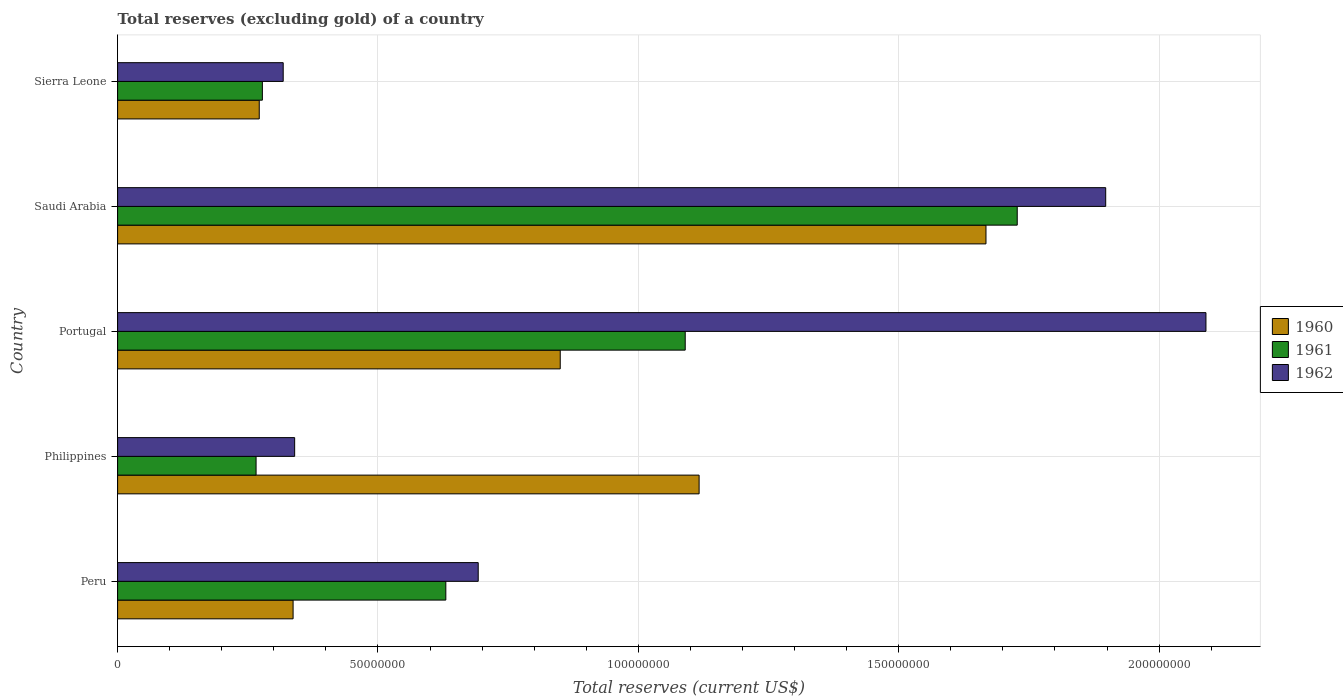How many groups of bars are there?
Your answer should be compact. 5. Are the number of bars on each tick of the Y-axis equal?
Offer a terse response. Yes. How many bars are there on the 3rd tick from the top?
Give a very brief answer. 3. In how many cases, is the number of bars for a given country not equal to the number of legend labels?
Provide a short and direct response. 0. What is the total reserves (excluding gold) in 1962 in Saudi Arabia?
Provide a succinct answer. 1.90e+08. Across all countries, what is the maximum total reserves (excluding gold) in 1960?
Your answer should be very brief. 1.67e+08. Across all countries, what is the minimum total reserves (excluding gold) in 1960?
Provide a succinct answer. 2.72e+07. In which country was the total reserves (excluding gold) in 1961 maximum?
Your response must be concise. Saudi Arabia. In which country was the total reserves (excluding gold) in 1962 minimum?
Keep it short and to the point. Sierra Leone. What is the total total reserves (excluding gold) in 1960 in the graph?
Make the answer very short. 4.24e+08. What is the difference between the total reserves (excluding gold) in 1960 in Saudi Arabia and that in Sierra Leone?
Offer a terse response. 1.40e+08. What is the difference between the total reserves (excluding gold) in 1960 in Peru and the total reserves (excluding gold) in 1961 in Portugal?
Ensure brevity in your answer.  -7.53e+07. What is the average total reserves (excluding gold) in 1961 per country?
Offer a terse response. 7.98e+07. What is the difference between the total reserves (excluding gold) in 1960 and total reserves (excluding gold) in 1962 in Sierra Leone?
Offer a very short reply. -4.60e+06. What is the ratio of the total reserves (excluding gold) in 1962 in Philippines to that in Portugal?
Give a very brief answer. 0.16. Is the difference between the total reserves (excluding gold) in 1960 in Peru and Sierra Leone greater than the difference between the total reserves (excluding gold) in 1962 in Peru and Sierra Leone?
Provide a succinct answer. No. What is the difference between the highest and the second highest total reserves (excluding gold) in 1962?
Your answer should be compact. 1.92e+07. What is the difference between the highest and the lowest total reserves (excluding gold) in 1960?
Offer a terse response. 1.40e+08. In how many countries, is the total reserves (excluding gold) in 1961 greater than the average total reserves (excluding gold) in 1961 taken over all countries?
Provide a short and direct response. 2. Is the sum of the total reserves (excluding gold) in 1961 in Peru and Portugal greater than the maximum total reserves (excluding gold) in 1962 across all countries?
Provide a succinct answer. No. What does the 3rd bar from the top in Portugal represents?
Ensure brevity in your answer.  1960. How many bars are there?
Provide a succinct answer. 15. What is the difference between two consecutive major ticks on the X-axis?
Offer a very short reply. 5.00e+07. Where does the legend appear in the graph?
Give a very brief answer. Center right. How many legend labels are there?
Your answer should be very brief. 3. What is the title of the graph?
Your answer should be very brief. Total reserves (excluding gold) of a country. Does "1983" appear as one of the legend labels in the graph?
Provide a short and direct response. No. What is the label or title of the X-axis?
Provide a short and direct response. Total reserves (current US$). What is the Total reserves (current US$) of 1960 in Peru?
Your answer should be compact. 3.37e+07. What is the Total reserves (current US$) of 1961 in Peru?
Give a very brief answer. 6.30e+07. What is the Total reserves (current US$) in 1962 in Peru?
Ensure brevity in your answer.  6.92e+07. What is the Total reserves (current US$) in 1960 in Philippines?
Ensure brevity in your answer.  1.12e+08. What is the Total reserves (current US$) in 1961 in Philippines?
Offer a very short reply. 2.66e+07. What is the Total reserves (current US$) of 1962 in Philippines?
Your response must be concise. 3.40e+07. What is the Total reserves (current US$) in 1960 in Portugal?
Offer a terse response. 8.50e+07. What is the Total reserves (current US$) in 1961 in Portugal?
Your answer should be very brief. 1.09e+08. What is the Total reserves (current US$) in 1962 in Portugal?
Your answer should be very brief. 2.09e+08. What is the Total reserves (current US$) of 1960 in Saudi Arabia?
Your answer should be very brief. 1.67e+08. What is the Total reserves (current US$) of 1961 in Saudi Arabia?
Give a very brief answer. 1.73e+08. What is the Total reserves (current US$) of 1962 in Saudi Arabia?
Offer a terse response. 1.90e+08. What is the Total reserves (current US$) of 1960 in Sierra Leone?
Make the answer very short. 2.72e+07. What is the Total reserves (current US$) of 1961 in Sierra Leone?
Make the answer very short. 2.78e+07. What is the Total reserves (current US$) in 1962 in Sierra Leone?
Offer a terse response. 3.18e+07. Across all countries, what is the maximum Total reserves (current US$) of 1960?
Give a very brief answer. 1.67e+08. Across all countries, what is the maximum Total reserves (current US$) of 1961?
Provide a succinct answer. 1.73e+08. Across all countries, what is the maximum Total reserves (current US$) in 1962?
Your response must be concise. 2.09e+08. Across all countries, what is the minimum Total reserves (current US$) in 1960?
Offer a terse response. 2.72e+07. Across all countries, what is the minimum Total reserves (current US$) of 1961?
Give a very brief answer. 2.66e+07. Across all countries, what is the minimum Total reserves (current US$) in 1962?
Offer a very short reply. 3.18e+07. What is the total Total reserves (current US$) in 1960 in the graph?
Keep it short and to the point. 4.24e+08. What is the total Total reserves (current US$) of 1961 in the graph?
Offer a terse response. 3.99e+08. What is the total Total reserves (current US$) in 1962 in the graph?
Give a very brief answer. 5.34e+08. What is the difference between the Total reserves (current US$) of 1960 in Peru and that in Philippines?
Keep it short and to the point. -7.80e+07. What is the difference between the Total reserves (current US$) of 1961 in Peru and that in Philippines?
Your response must be concise. 3.64e+07. What is the difference between the Total reserves (current US$) in 1962 in Peru and that in Philippines?
Offer a terse response. 3.52e+07. What is the difference between the Total reserves (current US$) in 1960 in Peru and that in Portugal?
Your answer should be very brief. -5.13e+07. What is the difference between the Total reserves (current US$) in 1961 in Peru and that in Portugal?
Offer a terse response. -4.60e+07. What is the difference between the Total reserves (current US$) in 1962 in Peru and that in Portugal?
Keep it short and to the point. -1.40e+08. What is the difference between the Total reserves (current US$) of 1960 in Peru and that in Saudi Arabia?
Offer a terse response. -1.33e+08. What is the difference between the Total reserves (current US$) in 1961 in Peru and that in Saudi Arabia?
Your answer should be compact. -1.10e+08. What is the difference between the Total reserves (current US$) in 1962 in Peru and that in Saudi Arabia?
Offer a terse response. -1.20e+08. What is the difference between the Total reserves (current US$) in 1960 in Peru and that in Sierra Leone?
Offer a terse response. 6.50e+06. What is the difference between the Total reserves (current US$) in 1961 in Peru and that in Sierra Leone?
Your answer should be compact. 3.52e+07. What is the difference between the Total reserves (current US$) in 1962 in Peru and that in Sierra Leone?
Provide a short and direct response. 3.74e+07. What is the difference between the Total reserves (current US$) in 1960 in Philippines and that in Portugal?
Offer a very short reply. 2.67e+07. What is the difference between the Total reserves (current US$) of 1961 in Philippines and that in Portugal?
Make the answer very short. -8.24e+07. What is the difference between the Total reserves (current US$) of 1962 in Philippines and that in Portugal?
Your answer should be compact. -1.75e+08. What is the difference between the Total reserves (current US$) of 1960 in Philippines and that in Saudi Arabia?
Make the answer very short. -5.51e+07. What is the difference between the Total reserves (current US$) in 1961 in Philippines and that in Saudi Arabia?
Provide a succinct answer. -1.46e+08. What is the difference between the Total reserves (current US$) in 1962 in Philippines and that in Saudi Arabia?
Your response must be concise. -1.56e+08. What is the difference between the Total reserves (current US$) of 1960 in Philippines and that in Sierra Leone?
Your answer should be compact. 8.45e+07. What is the difference between the Total reserves (current US$) in 1961 in Philippines and that in Sierra Leone?
Your response must be concise. -1.21e+06. What is the difference between the Total reserves (current US$) in 1962 in Philippines and that in Sierra Leone?
Provide a succinct answer. 2.20e+06. What is the difference between the Total reserves (current US$) in 1960 in Portugal and that in Saudi Arabia?
Provide a succinct answer. -8.18e+07. What is the difference between the Total reserves (current US$) of 1961 in Portugal and that in Saudi Arabia?
Provide a short and direct response. -6.38e+07. What is the difference between the Total reserves (current US$) of 1962 in Portugal and that in Saudi Arabia?
Give a very brief answer. 1.92e+07. What is the difference between the Total reserves (current US$) of 1960 in Portugal and that in Sierra Leone?
Provide a succinct answer. 5.78e+07. What is the difference between the Total reserves (current US$) of 1961 in Portugal and that in Sierra Leone?
Make the answer very short. 8.12e+07. What is the difference between the Total reserves (current US$) of 1962 in Portugal and that in Sierra Leone?
Your answer should be very brief. 1.77e+08. What is the difference between the Total reserves (current US$) of 1960 in Saudi Arabia and that in Sierra Leone?
Provide a succinct answer. 1.40e+08. What is the difference between the Total reserves (current US$) of 1961 in Saudi Arabia and that in Sierra Leone?
Provide a short and direct response. 1.45e+08. What is the difference between the Total reserves (current US$) of 1962 in Saudi Arabia and that in Sierra Leone?
Your answer should be very brief. 1.58e+08. What is the difference between the Total reserves (current US$) in 1960 in Peru and the Total reserves (current US$) in 1961 in Philippines?
Your response must be concise. 7.11e+06. What is the difference between the Total reserves (current US$) of 1960 in Peru and the Total reserves (current US$) of 1962 in Philippines?
Provide a succinct answer. -3.00e+05. What is the difference between the Total reserves (current US$) in 1961 in Peru and the Total reserves (current US$) in 1962 in Philippines?
Give a very brief answer. 2.90e+07. What is the difference between the Total reserves (current US$) in 1960 in Peru and the Total reserves (current US$) in 1961 in Portugal?
Offer a very short reply. -7.53e+07. What is the difference between the Total reserves (current US$) in 1960 in Peru and the Total reserves (current US$) in 1962 in Portugal?
Make the answer very short. -1.75e+08. What is the difference between the Total reserves (current US$) of 1961 in Peru and the Total reserves (current US$) of 1962 in Portugal?
Your response must be concise. -1.46e+08. What is the difference between the Total reserves (current US$) in 1960 in Peru and the Total reserves (current US$) in 1961 in Saudi Arabia?
Offer a terse response. -1.39e+08. What is the difference between the Total reserves (current US$) in 1960 in Peru and the Total reserves (current US$) in 1962 in Saudi Arabia?
Give a very brief answer. -1.56e+08. What is the difference between the Total reserves (current US$) in 1961 in Peru and the Total reserves (current US$) in 1962 in Saudi Arabia?
Provide a short and direct response. -1.27e+08. What is the difference between the Total reserves (current US$) of 1960 in Peru and the Total reserves (current US$) of 1961 in Sierra Leone?
Your answer should be compact. 5.90e+06. What is the difference between the Total reserves (current US$) of 1960 in Peru and the Total reserves (current US$) of 1962 in Sierra Leone?
Make the answer very short. 1.90e+06. What is the difference between the Total reserves (current US$) in 1961 in Peru and the Total reserves (current US$) in 1962 in Sierra Leone?
Your answer should be compact. 3.12e+07. What is the difference between the Total reserves (current US$) of 1960 in Philippines and the Total reserves (current US$) of 1961 in Portugal?
Offer a terse response. 2.67e+06. What is the difference between the Total reserves (current US$) of 1960 in Philippines and the Total reserves (current US$) of 1962 in Portugal?
Keep it short and to the point. -9.73e+07. What is the difference between the Total reserves (current US$) in 1961 in Philippines and the Total reserves (current US$) in 1962 in Portugal?
Make the answer very short. -1.82e+08. What is the difference between the Total reserves (current US$) in 1960 in Philippines and the Total reserves (current US$) in 1961 in Saudi Arabia?
Provide a short and direct response. -6.11e+07. What is the difference between the Total reserves (current US$) in 1960 in Philippines and the Total reserves (current US$) in 1962 in Saudi Arabia?
Provide a succinct answer. -7.81e+07. What is the difference between the Total reserves (current US$) of 1961 in Philippines and the Total reserves (current US$) of 1962 in Saudi Arabia?
Your response must be concise. -1.63e+08. What is the difference between the Total reserves (current US$) in 1960 in Philippines and the Total reserves (current US$) in 1961 in Sierra Leone?
Keep it short and to the point. 8.39e+07. What is the difference between the Total reserves (current US$) in 1960 in Philippines and the Total reserves (current US$) in 1962 in Sierra Leone?
Ensure brevity in your answer.  7.99e+07. What is the difference between the Total reserves (current US$) of 1961 in Philippines and the Total reserves (current US$) of 1962 in Sierra Leone?
Make the answer very short. -5.21e+06. What is the difference between the Total reserves (current US$) in 1960 in Portugal and the Total reserves (current US$) in 1961 in Saudi Arabia?
Offer a very short reply. -8.78e+07. What is the difference between the Total reserves (current US$) of 1960 in Portugal and the Total reserves (current US$) of 1962 in Saudi Arabia?
Your answer should be compact. -1.05e+08. What is the difference between the Total reserves (current US$) in 1961 in Portugal and the Total reserves (current US$) in 1962 in Saudi Arabia?
Offer a very short reply. -8.07e+07. What is the difference between the Total reserves (current US$) in 1960 in Portugal and the Total reserves (current US$) in 1961 in Sierra Leone?
Offer a terse response. 5.72e+07. What is the difference between the Total reserves (current US$) of 1960 in Portugal and the Total reserves (current US$) of 1962 in Sierra Leone?
Make the answer very short. 5.32e+07. What is the difference between the Total reserves (current US$) in 1961 in Portugal and the Total reserves (current US$) in 1962 in Sierra Leone?
Your response must be concise. 7.72e+07. What is the difference between the Total reserves (current US$) in 1960 in Saudi Arabia and the Total reserves (current US$) in 1961 in Sierra Leone?
Provide a short and direct response. 1.39e+08. What is the difference between the Total reserves (current US$) in 1960 in Saudi Arabia and the Total reserves (current US$) in 1962 in Sierra Leone?
Offer a terse response. 1.35e+08. What is the difference between the Total reserves (current US$) of 1961 in Saudi Arabia and the Total reserves (current US$) of 1962 in Sierra Leone?
Offer a terse response. 1.41e+08. What is the average Total reserves (current US$) in 1960 per country?
Provide a succinct answer. 8.49e+07. What is the average Total reserves (current US$) of 1961 per country?
Your answer should be very brief. 7.98e+07. What is the average Total reserves (current US$) in 1962 per country?
Make the answer very short. 1.07e+08. What is the difference between the Total reserves (current US$) of 1960 and Total reserves (current US$) of 1961 in Peru?
Provide a succinct answer. -2.93e+07. What is the difference between the Total reserves (current US$) in 1960 and Total reserves (current US$) in 1962 in Peru?
Make the answer very short. -3.55e+07. What is the difference between the Total reserves (current US$) in 1961 and Total reserves (current US$) in 1962 in Peru?
Your answer should be compact. -6.22e+06. What is the difference between the Total reserves (current US$) in 1960 and Total reserves (current US$) in 1961 in Philippines?
Make the answer very short. 8.51e+07. What is the difference between the Total reserves (current US$) in 1960 and Total reserves (current US$) in 1962 in Philippines?
Offer a terse response. 7.77e+07. What is the difference between the Total reserves (current US$) of 1961 and Total reserves (current US$) of 1962 in Philippines?
Provide a succinct answer. -7.41e+06. What is the difference between the Total reserves (current US$) of 1960 and Total reserves (current US$) of 1961 in Portugal?
Provide a short and direct response. -2.40e+07. What is the difference between the Total reserves (current US$) of 1960 and Total reserves (current US$) of 1962 in Portugal?
Offer a very short reply. -1.24e+08. What is the difference between the Total reserves (current US$) in 1961 and Total reserves (current US$) in 1962 in Portugal?
Offer a terse response. -1.00e+08. What is the difference between the Total reserves (current US$) in 1960 and Total reserves (current US$) in 1961 in Saudi Arabia?
Provide a succinct answer. -6.00e+06. What is the difference between the Total reserves (current US$) of 1960 and Total reserves (current US$) of 1962 in Saudi Arabia?
Give a very brief answer. -2.30e+07. What is the difference between the Total reserves (current US$) of 1961 and Total reserves (current US$) of 1962 in Saudi Arabia?
Your response must be concise. -1.70e+07. What is the difference between the Total reserves (current US$) in 1960 and Total reserves (current US$) in 1961 in Sierra Leone?
Keep it short and to the point. -6.00e+05. What is the difference between the Total reserves (current US$) of 1960 and Total reserves (current US$) of 1962 in Sierra Leone?
Your answer should be very brief. -4.60e+06. What is the difference between the Total reserves (current US$) of 1961 and Total reserves (current US$) of 1962 in Sierra Leone?
Your answer should be very brief. -4.00e+06. What is the ratio of the Total reserves (current US$) in 1960 in Peru to that in Philippines?
Ensure brevity in your answer.  0.3. What is the ratio of the Total reserves (current US$) in 1961 in Peru to that in Philippines?
Offer a terse response. 2.37. What is the ratio of the Total reserves (current US$) in 1962 in Peru to that in Philippines?
Your answer should be very brief. 2.04. What is the ratio of the Total reserves (current US$) of 1960 in Peru to that in Portugal?
Ensure brevity in your answer.  0.4. What is the ratio of the Total reserves (current US$) of 1961 in Peru to that in Portugal?
Keep it short and to the point. 0.58. What is the ratio of the Total reserves (current US$) in 1962 in Peru to that in Portugal?
Offer a terse response. 0.33. What is the ratio of the Total reserves (current US$) in 1960 in Peru to that in Saudi Arabia?
Your response must be concise. 0.2. What is the ratio of the Total reserves (current US$) of 1961 in Peru to that in Saudi Arabia?
Give a very brief answer. 0.36. What is the ratio of the Total reserves (current US$) of 1962 in Peru to that in Saudi Arabia?
Make the answer very short. 0.36. What is the ratio of the Total reserves (current US$) of 1960 in Peru to that in Sierra Leone?
Offer a very short reply. 1.24. What is the ratio of the Total reserves (current US$) in 1961 in Peru to that in Sierra Leone?
Offer a very short reply. 2.27. What is the ratio of the Total reserves (current US$) in 1962 in Peru to that in Sierra Leone?
Your answer should be very brief. 2.18. What is the ratio of the Total reserves (current US$) in 1960 in Philippines to that in Portugal?
Provide a short and direct response. 1.31. What is the ratio of the Total reserves (current US$) of 1961 in Philippines to that in Portugal?
Offer a terse response. 0.24. What is the ratio of the Total reserves (current US$) in 1962 in Philippines to that in Portugal?
Offer a very short reply. 0.16. What is the ratio of the Total reserves (current US$) of 1960 in Philippines to that in Saudi Arabia?
Offer a very short reply. 0.67. What is the ratio of the Total reserves (current US$) in 1961 in Philippines to that in Saudi Arabia?
Offer a terse response. 0.15. What is the ratio of the Total reserves (current US$) in 1962 in Philippines to that in Saudi Arabia?
Your response must be concise. 0.18. What is the ratio of the Total reserves (current US$) of 1960 in Philippines to that in Sierra Leone?
Make the answer very short. 4.11. What is the ratio of the Total reserves (current US$) of 1961 in Philippines to that in Sierra Leone?
Your response must be concise. 0.96. What is the ratio of the Total reserves (current US$) in 1962 in Philippines to that in Sierra Leone?
Offer a very short reply. 1.07. What is the ratio of the Total reserves (current US$) in 1960 in Portugal to that in Saudi Arabia?
Your response must be concise. 0.51. What is the ratio of the Total reserves (current US$) of 1961 in Portugal to that in Saudi Arabia?
Offer a very short reply. 0.63. What is the ratio of the Total reserves (current US$) of 1962 in Portugal to that in Saudi Arabia?
Provide a succinct answer. 1.1. What is the ratio of the Total reserves (current US$) in 1960 in Portugal to that in Sierra Leone?
Make the answer very short. 3.12. What is the ratio of the Total reserves (current US$) of 1961 in Portugal to that in Sierra Leone?
Keep it short and to the point. 3.92. What is the ratio of the Total reserves (current US$) in 1962 in Portugal to that in Sierra Leone?
Provide a short and direct response. 6.57. What is the ratio of the Total reserves (current US$) in 1960 in Saudi Arabia to that in Sierra Leone?
Make the answer very short. 6.13. What is the ratio of the Total reserves (current US$) in 1961 in Saudi Arabia to that in Sierra Leone?
Your answer should be compact. 6.21. What is the ratio of the Total reserves (current US$) of 1962 in Saudi Arabia to that in Sierra Leone?
Your answer should be very brief. 5.97. What is the difference between the highest and the second highest Total reserves (current US$) of 1960?
Make the answer very short. 5.51e+07. What is the difference between the highest and the second highest Total reserves (current US$) in 1961?
Your answer should be very brief. 6.38e+07. What is the difference between the highest and the second highest Total reserves (current US$) of 1962?
Keep it short and to the point. 1.92e+07. What is the difference between the highest and the lowest Total reserves (current US$) of 1960?
Provide a short and direct response. 1.40e+08. What is the difference between the highest and the lowest Total reserves (current US$) of 1961?
Give a very brief answer. 1.46e+08. What is the difference between the highest and the lowest Total reserves (current US$) in 1962?
Your response must be concise. 1.77e+08. 